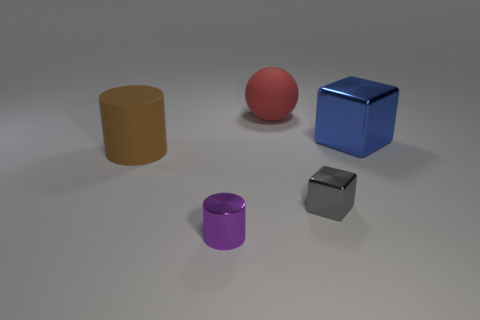Add 2 blue things. How many objects exist? 7 Subtract all cylinders. How many objects are left? 3 Subtract all big brown rubber objects. Subtract all tiny purple metallic cylinders. How many objects are left? 3 Add 1 tiny objects. How many tiny objects are left? 3 Add 3 blue metal objects. How many blue metal objects exist? 4 Subtract 0 yellow cubes. How many objects are left? 5 